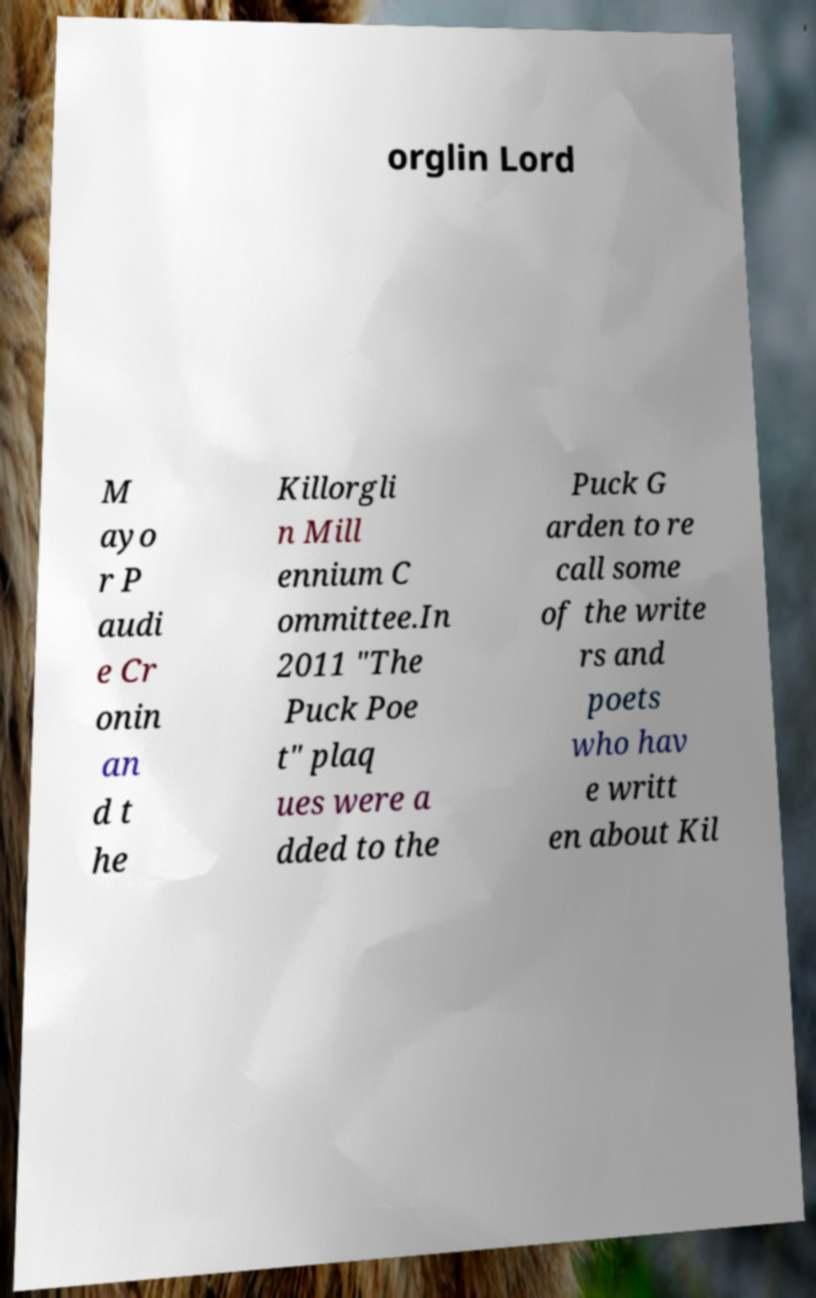Can you read and provide the text displayed in the image?This photo seems to have some interesting text. Can you extract and type it out for me? orglin Lord M ayo r P audi e Cr onin an d t he Killorgli n Mill ennium C ommittee.In 2011 "The Puck Poe t" plaq ues were a dded to the Puck G arden to re call some of the write rs and poets who hav e writt en about Kil 